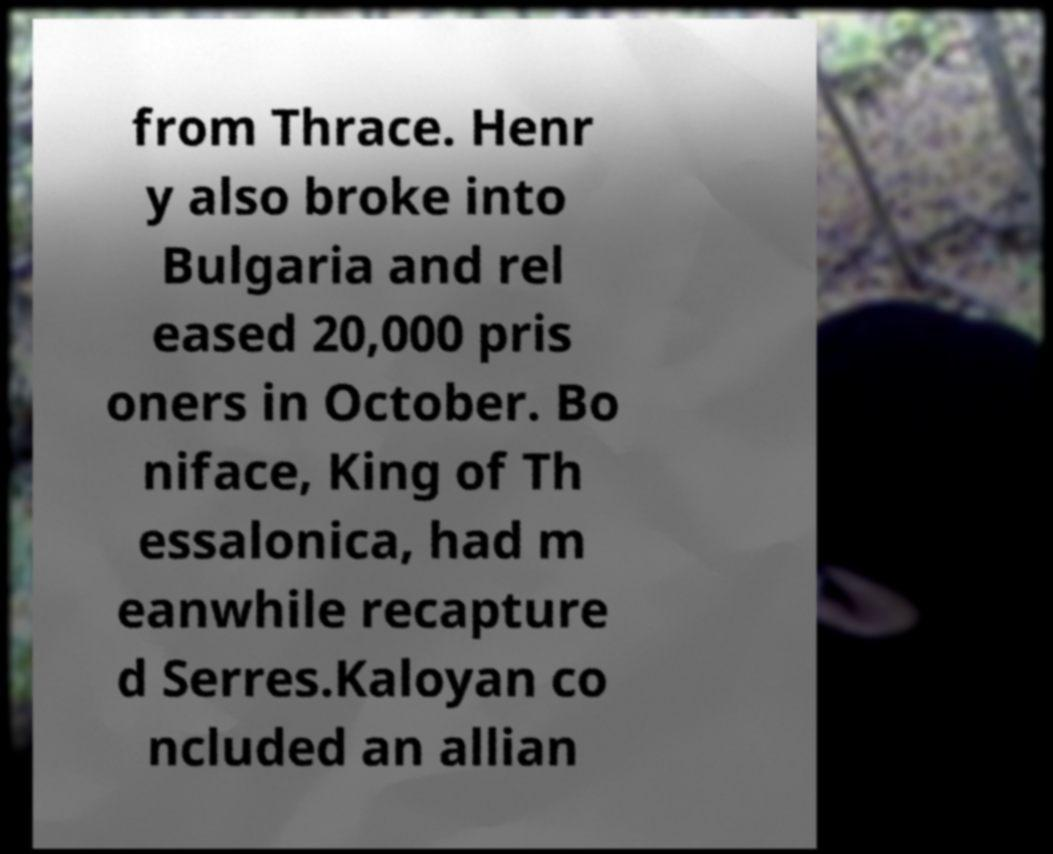For documentation purposes, I need the text within this image transcribed. Could you provide that? from Thrace. Henr y also broke into Bulgaria and rel eased 20,000 pris oners in October. Bo niface, King of Th essalonica, had m eanwhile recapture d Serres.Kaloyan co ncluded an allian 